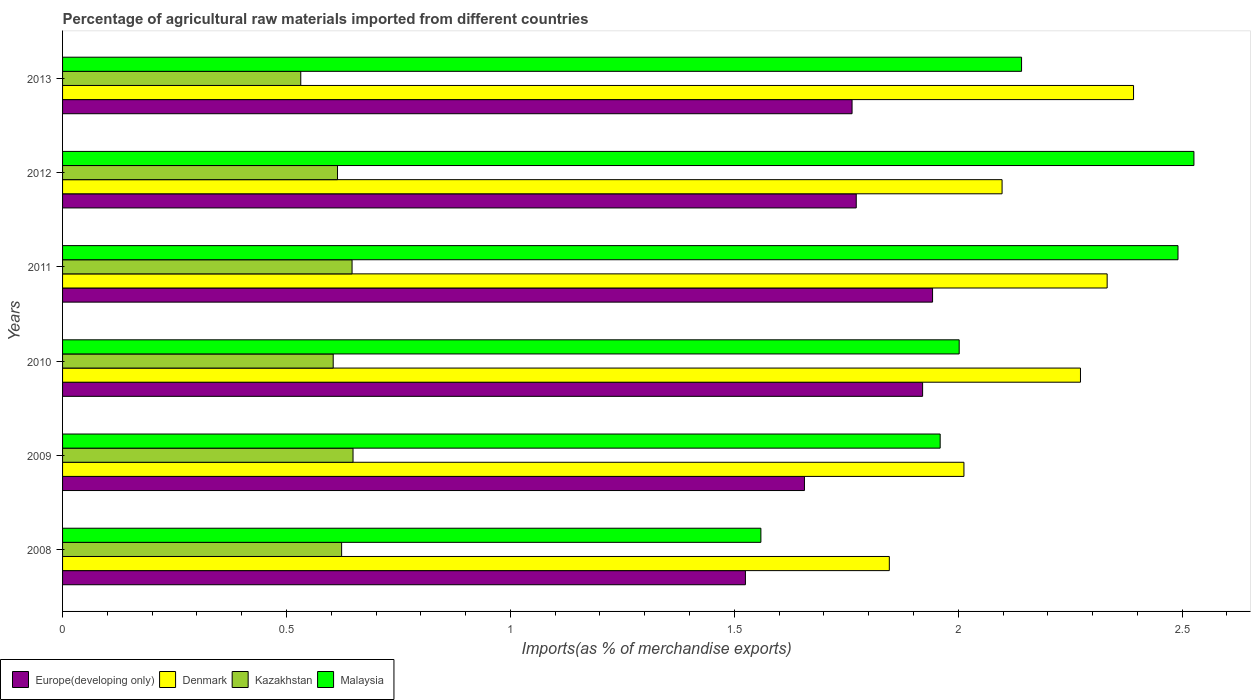Are the number of bars per tick equal to the number of legend labels?
Offer a terse response. Yes. What is the label of the 4th group of bars from the top?
Ensure brevity in your answer.  2010. What is the percentage of imports to different countries in Denmark in 2008?
Give a very brief answer. 1.85. Across all years, what is the maximum percentage of imports to different countries in Malaysia?
Make the answer very short. 2.53. Across all years, what is the minimum percentage of imports to different countries in Malaysia?
Your answer should be very brief. 1.56. What is the total percentage of imports to different countries in Malaysia in the graph?
Make the answer very short. 12.68. What is the difference between the percentage of imports to different countries in Europe(developing only) in 2008 and that in 2009?
Keep it short and to the point. -0.13. What is the difference between the percentage of imports to different countries in Malaysia in 2008 and the percentage of imports to different countries in Denmark in 2012?
Provide a short and direct response. -0.54. What is the average percentage of imports to different countries in Kazakhstan per year?
Your answer should be very brief. 0.61. In the year 2011, what is the difference between the percentage of imports to different countries in Europe(developing only) and percentage of imports to different countries in Malaysia?
Give a very brief answer. -0.55. What is the ratio of the percentage of imports to different countries in Malaysia in 2008 to that in 2013?
Keep it short and to the point. 0.73. Is the percentage of imports to different countries in Kazakhstan in 2008 less than that in 2010?
Your response must be concise. No. What is the difference between the highest and the second highest percentage of imports to different countries in Kazakhstan?
Provide a short and direct response. 0. What is the difference between the highest and the lowest percentage of imports to different countries in Malaysia?
Your answer should be very brief. 0.97. In how many years, is the percentage of imports to different countries in Kazakhstan greater than the average percentage of imports to different countries in Kazakhstan taken over all years?
Your answer should be compact. 4. What does the 1st bar from the bottom in 2008 represents?
Provide a short and direct response. Europe(developing only). Are all the bars in the graph horizontal?
Give a very brief answer. Yes. Are the values on the major ticks of X-axis written in scientific E-notation?
Offer a very short reply. No. Does the graph contain grids?
Your response must be concise. No. How many legend labels are there?
Keep it short and to the point. 4. How are the legend labels stacked?
Offer a terse response. Horizontal. What is the title of the graph?
Make the answer very short. Percentage of agricultural raw materials imported from different countries. Does "India" appear as one of the legend labels in the graph?
Your response must be concise. No. What is the label or title of the X-axis?
Make the answer very short. Imports(as % of merchandise exports). What is the label or title of the Y-axis?
Keep it short and to the point. Years. What is the Imports(as % of merchandise exports) in Europe(developing only) in 2008?
Provide a short and direct response. 1.52. What is the Imports(as % of merchandise exports) in Denmark in 2008?
Give a very brief answer. 1.85. What is the Imports(as % of merchandise exports) of Kazakhstan in 2008?
Your answer should be very brief. 0.62. What is the Imports(as % of merchandise exports) in Malaysia in 2008?
Your answer should be very brief. 1.56. What is the Imports(as % of merchandise exports) in Europe(developing only) in 2009?
Your response must be concise. 1.66. What is the Imports(as % of merchandise exports) in Denmark in 2009?
Your answer should be very brief. 2.01. What is the Imports(as % of merchandise exports) in Kazakhstan in 2009?
Provide a succinct answer. 0.65. What is the Imports(as % of merchandise exports) in Malaysia in 2009?
Your response must be concise. 1.96. What is the Imports(as % of merchandise exports) in Europe(developing only) in 2010?
Keep it short and to the point. 1.92. What is the Imports(as % of merchandise exports) in Denmark in 2010?
Offer a terse response. 2.27. What is the Imports(as % of merchandise exports) of Kazakhstan in 2010?
Provide a succinct answer. 0.6. What is the Imports(as % of merchandise exports) in Malaysia in 2010?
Provide a short and direct response. 2. What is the Imports(as % of merchandise exports) of Europe(developing only) in 2011?
Keep it short and to the point. 1.94. What is the Imports(as % of merchandise exports) of Denmark in 2011?
Give a very brief answer. 2.33. What is the Imports(as % of merchandise exports) of Kazakhstan in 2011?
Provide a short and direct response. 0.65. What is the Imports(as % of merchandise exports) in Malaysia in 2011?
Provide a short and direct response. 2.49. What is the Imports(as % of merchandise exports) of Europe(developing only) in 2012?
Provide a short and direct response. 1.77. What is the Imports(as % of merchandise exports) in Denmark in 2012?
Your response must be concise. 2.1. What is the Imports(as % of merchandise exports) in Kazakhstan in 2012?
Ensure brevity in your answer.  0.61. What is the Imports(as % of merchandise exports) in Malaysia in 2012?
Make the answer very short. 2.53. What is the Imports(as % of merchandise exports) in Europe(developing only) in 2013?
Provide a succinct answer. 1.76. What is the Imports(as % of merchandise exports) in Denmark in 2013?
Ensure brevity in your answer.  2.39. What is the Imports(as % of merchandise exports) in Kazakhstan in 2013?
Offer a very short reply. 0.53. What is the Imports(as % of merchandise exports) of Malaysia in 2013?
Ensure brevity in your answer.  2.14. Across all years, what is the maximum Imports(as % of merchandise exports) of Europe(developing only)?
Ensure brevity in your answer.  1.94. Across all years, what is the maximum Imports(as % of merchandise exports) of Denmark?
Your answer should be compact. 2.39. Across all years, what is the maximum Imports(as % of merchandise exports) of Kazakhstan?
Offer a terse response. 0.65. Across all years, what is the maximum Imports(as % of merchandise exports) in Malaysia?
Give a very brief answer. 2.53. Across all years, what is the minimum Imports(as % of merchandise exports) of Europe(developing only)?
Offer a very short reply. 1.52. Across all years, what is the minimum Imports(as % of merchandise exports) in Denmark?
Make the answer very short. 1.85. Across all years, what is the minimum Imports(as % of merchandise exports) in Kazakhstan?
Your answer should be compact. 0.53. Across all years, what is the minimum Imports(as % of merchandise exports) in Malaysia?
Ensure brevity in your answer.  1.56. What is the total Imports(as % of merchandise exports) of Europe(developing only) in the graph?
Give a very brief answer. 10.58. What is the total Imports(as % of merchandise exports) of Denmark in the graph?
Your response must be concise. 12.95. What is the total Imports(as % of merchandise exports) of Kazakhstan in the graph?
Your response must be concise. 3.67. What is the total Imports(as % of merchandise exports) of Malaysia in the graph?
Your answer should be compact. 12.68. What is the difference between the Imports(as % of merchandise exports) of Europe(developing only) in 2008 and that in 2009?
Offer a very short reply. -0.13. What is the difference between the Imports(as % of merchandise exports) of Denmark in 2008 and that in 2009?
Keep it short and to the point. -0.17. What is the difference between the Imports(as % of merchandise exports) of Kazakhstan in 2008 and that in 2009?
Ensure brevity in your answer.  -0.03. What is the difference between the Imports(as % of merchandise exports) in Malaysia in 2008 and that in 2009?
Provide a short and direct response. -0.4. What is the difference between the Imports(as % of merchandise exports) in Europe(developing only) in 2008 and that in 2010?
Your answer should be compact. -0.4. What is the difference between the Imports(as % of merchandise exports) in Denmark in 2008 and that in 2010?
Make the answer very short. -0.43. What is the difference between the Imports(as % of merchandise exports) of Kazakhstan in 2008 and that in 2010?
Make the answer very short. 0.02. What is the difference between the Imports(as % of merchandise exports) in Malaysia in 2008 and that in 2010?
Offer a very short reply. -0.44. What is the difference between the Imports(as % of merchandise exports) in Europe(developing only) in 2008 and that in 2011?
Your answer should be compact. -0.42. What is the difference between the Imports(as % of merchandise exports) in Denmark in 2008 and that in 2011?
Give a very brief answer. -0.49. What is the difference between the Imports(as % of merchandise exports) of Kazakhstan in 2008 and that in 2011?
Keep it short and to the point. -0.02. What is the difference between the Imports(as % of merchandise exports) in Malaysia in 2008 and that in 2011?
Your answer should be compact. -0.93. What is the difference between the Imports(as % of merchandise exports) in Europe(developing only) in 2008 and that in 2012?
Provide a short and direct response. -0.25. What is the difference between the Imports(as % of merchandise exports) of Denmark in 2008 and that in 2012?
Make the answer very short. -0.25. What is the difference between the Imports(as % of merchandise exports) in Kazakhstan in 2008 and that in 2012?
Provide a short and direct response. 0.01. What is the difference between the Imports(as % of merchandise exports) of Malaysia in 2008 and that in 2012?
Provide a short and direct response. -0.97. What is the difference between the Imports(as % of merchandise exports) of Europe(developing only) in 2008 and that in 2013?
Ensure brevity in your answer.  -0.24. What is the difference between the Imports(as % of merchandise exports) of Denmark in 2008 and that in 2013?
Give a very brief answer. -0.55. What is the difference between the Imports(as % of merchandise exports) in Kazakhstan in 2008 and that in 2013?
Provide a short and direct response. 0.09. What is the difference between the Imports(as % of merchandise exports) in Malaysia in 2008 and that in 2013?
Provide a succinct answer. -0.58. What is the difference between the Imports(as % of merchandise exports) of Europe(developing only) in 2009 and that in 2010?
Offer a very short reply. -0.26. What is the difference between the Imports(as % of merchandise exports) in Denmark in 2009 and that in 2010?
Give a very brief answer. -0.26. What is the difference between the Imports(as % of merchandise exports) of Kazakhstan in 2009 and that in 2010?
Provide a short and direct response. 0.04. What is the difference between the Imports(as % of merchandise exports) in Malaysia in 2009 and that in 2010?
Ensure brevity in your answer.  -0.04. What is the difference between the Imports(as % of merchandise exports) in Europe(developing only) in 2009 and that in 2011?
Keep it short and to the point. -0.29. What is the difference between the Imports(as % of merchandise exports) in Denmark in 2009 and that in 2011?
Provide a succinct answer. -0.32. What is the difference between the Imports(as % of merchandise exports) of Kazakhstan in 2009 and that in 2011?
Provide a succinct answer. 0. What is the difference between the Imports(as % of merchandise exports) of Malaysia in 2009 and that in 2011?
Your response must be concise. -0.53. What is the difference between the Imports(as % of merchandise exports) in Europe(developing only) in 2009 and that in 2012?
Keep it short and to the point. -0.12. What is the difference between the Imports(as % of merchandise exports) of Denmark in 2009 and that in 2012?
Your answer should be very brief. -0.09. What is the difference between the Imports(as % of merchandise exports) of Kazakhstan in 2009 and that in 2012?
Provide a short and direct response. 0.03. What is the difference between the Imports(as % of merchandise exports) of Malaysia in 2009 and that in 2012?
Provide a short and direct response. -0.57. What is the difference between the Imports(as % of merchandise exports) of Europe(developing only) in 2009 and that in 2013?
Ensure brevity in your answer.  -0.11. What is the difference between the Imports(as % of merchandise exports) in Denmark in 2009 and that in 2013?
Ensure brevity in your answer.  -0.38. What is the difference between the Imports(as % of merchandise exports) of Kazakhstan in 2009 and that in 2013?
Your answer should be very brief. 0.12. What is the difference between the Imports(as % of merchandise exports) of Malaysia in 2009 and that in 2013?
Your answer should be very brief. -0.18. What is the difference between the Imports(as % of merchandise exports) of Europe(developing only) in 2010 and that in 2011?
Provide a succinct answer. -0.02. What is the difference between the Imports(as % of merchandise exports) in Denmark in 2010 and that in 2011?
Your response must be concise. -0.06. What is the difference between the Imports(as % of merchandise exports) of Kazakhstan in 2010 and that in 2011?
Make the answer very short. -0.04. What is the difference between the Imports(as % of merchandise exports) in Malaysia in 2010 and that in 2011?
Your answer should be compact. -0.49. What is the difference between the Imports(as % of merchandise exports) in Europe(developing only) in 2010 and that in 2012?
Offer a very short reply. 0.15. What is the difference between the Imports(as % of merchandise exports) in Denmark in 2010 and that in 2012?
Your answer should be compact. 0.18. What is the difference between the Imports(as % of merchandise exports) of Kazakhstan in 2010 and that in 2012?
Your answer should be compact. -0.01. What is the difference between the Imports(as % of merchandise exports) of Malaysia in 2010 and that in 2012?
Offer a very short reply. -0.52. What is the difference between the Imports(as % of merchandise exports) in Europe(developing only) in 2010 and that in 2013?
Provide a succinct answer. 0.16. What is the difference between the Imports(as % of merchandise exports) in Denmark in 2010 and that in 2013?
Give a very brief answer. -0.12. What is the difference between the Imports(as % of merchandise exports) of Kazakhstan in 2010 and that in 2013?
Provide a succinct answer. 0.07. What is the difference between the Imports(as % of merchandise exports) in Malaysia in 2010 and that in 2013?
Provide a short and direct response. -0.14. What is the difference between the Imports(as % of merchandise exports) of Europe(developing only) in 2011 and that in 2012?
Make the answer very short. 0.17. What is the difference between the Imports(as % of merchandise exports) of Denmark in 2011 and that in 2012?
Your response must be concise. 0.23. What is the difference between the Imports(as % of merchandise exports) of Kazakhstan in 2011 and that in 2012?
Give a very brief answer. 0.03. What is the difference between the Imports(as % of merchandise exports) of Malaysia in 2011 and that in 2012?
Ensure brevity in your answer.  -0.04. What is the difference between the Imports(as % of merchandise exports) in Europe(developing only) in 2011 and that in 2013?
Your answer should be very brief. 0.18. What is the difference between the Imports(as % of merchandise exports) of Denmark in 2011 and that in 2013?
Keep it short and to the point. -0.06. What is the difference between the Imports(as % of merchandise exports) in Kazakhstan in 2011 and that in 2013?
Ensure brevity in your answer.  0.11. What is the difference between the Imports(as % of merchandise exports) in Malaysia in 2011 and that in 2013?
Your response must be concise. 0.35. What is the difference between the Imports(as % of merchandise exports) in Europe(developing only) in 2012 and that in 2013?
Provide a succinct answer. 0.01. What is the difference between the Imports(as % of merchandise exports) in Denmark in 2012 and that in 2013?
Provide a short and direct response. -0.29. What is the difference between the Imports(as % of merchandise exports) of Kazakhstan in 2012 and that in 2013?
Offer a very short reply. 0.08. What is the difference between the Imports(as % of merchandise exports) in Malaysia in 2012 and that in 2013?
Give a very brief answer. 0.38. What is the difference between the Imports(as % of merchandise exports) of Europe(developing only) in 2008 and the Imports(as % of merchandise exports) of Denmark in 2009?
Ensure brevity in your answer.  -0.49. What is the difference between the Imports(as % of merchandise exports) in Europe(developing only) in 2008 and the Imports(as % of merchandise exports) in Kazakhstan in 2009?
Your answer should be compact. 0.88. What is the difference between the Imports(as % of merchandise exports) of Europe(developing only) in 2008 and the Imports(as % of merchandise exports) of Malaysia in 2009?
Your response must be concise. -0.43. What is the difference between the Imports(as % of merchandise exports) of Denmark in 2008 and the Imports(as % of merchandise exports) of Kazakhstan in 2009?
Your answer should be very brief. 1.2. What is the difference between the Imports(as % of merchandise exports) in Denmark in 2008 and the Imports(as % of merchandise exports) in Malaysia in 2009?
Offer a very short reply. -0.11. What is the difference between the Imports(as % of merchandise exports) of Kazakhstan in 2008 and the Imports(as % of merchandise exports) of Malaysia in 2009?
Your response must be concise. -1.34. What is the difference between the Imports(as % of merchandise exports) of Europe(developing only) in 2008 and the Imports(as % of merchandise exports) of Denmark in 2010?
Give a very brief answer. -0.75. What is the difference between the Imports(as % of merchandise exports) of Europe(developing only) in 2008 and the Imports(as % of merchandise exports) of Kazakhstan in 2010?
Provide a short and direct response. 0.92. What is the difference between the Imports(as % of merchandise exports) in Europe(developing only) in 2008 and the Imports(as % of merchandise exports) in Malaysia in 2010?
Provide a short and direct response. -0.48. What is the difference between the Imports(as % of merchandise exports) of Denmark in 2008 and the Imports(as % of merchandise exports) of Kazakhstan in 2010?
Provide a succinct answer. 1.24. What is the difference between the Imports(as % of merchandise exports) of Denmark in 2008 and the Imports(as % of merchandise exports) of Malaysia in 2010?
Your answer should be very brief. -0.16. What is the difference between the Imports(as % of merchandise exports) of Kazakhstan in 2008 and the Imports(as % of merchandise exports) of Malaysia in 2010?
Give a very brief answer. -1.38. What is the difference between the Imports(as % of merchandise exports) of Europe(developing only) in 2008 and the Imports(as % of merchandise exports) of Denmark in 2011?
Provide a succinct answer. -0.81. What is the difference between the Imports(as % of merchandise exports) of Europe(developing only) in 2008 and the Imports(as % of merchandise exports) of Kazakhstan in 2011?
Provide a succinct answer. 0.88. What is the difference between the Imports(as % of merchandise exports) in Europe(developing only) in 2008 and the Imports(as % of merchandise exports) in Malaysia in 2011?
Provide a succinct answer. -0.97. What is the difference between the Imports(as % of merchandise exports) in Denmark in 2008 and the Imports(as % of merchandise exports) in Kazakhstan in 2011?
Your response must be concise. 1.2. What is the difference between the Imports(as % of merchandise exports) of Denmark in 2008 and the Imports(as % of merchandise exports) of Malaysia in 2011?
Make the answer very short. -0.64. What is the difference between the Imports(as % of merchandise exports) of Kazakhstan in 2008 and the Imports(as % of merchandise exports) of Malaysia in 2011?
Offer a terse response. -1.87. What is the difference between the Imports(as % of merchandise exports) of Europe(developing only) in 2008 and the Imports(as % of merchandise exports) of Denmark in 2012?
Your answer should be very brief. -0.57. What is the difference between the Imports(as % of merchandise exports) of Europe(developing only) in 2008 and the Imports(as % of merchandise exports) of Kazakhstan in 2012?
Your answer should be very brief. 0.91. What is the difference between the Imports(as % of merchandise exports) of Europe(developing only) in 2008 and the Imports(as % of merchandise exports) of Malaysia in 2012?
Offer a very short reply. -1. What is the difference between the Imports(as % of merchandise exports) of Denmark in 2008 and the Imports(as % of merchandise exports) of Kazakhstan in 2012?
Provide a short and direct response. 1.23. What is the difference between the Imports(as % of merchandise exports) of Denmark in 2008 and the Imports(as % of merchandise exports) of Malaysia in 2012?
Make the answer very short. -0.68. What is the difference between the Imports(as % of merchandise exports) in Kazakhstan in 2008 and the Imports(as % of merchandise exports) in Malaysia in 2012?
Your response must be concise. -1.9. What is the difference between the Imports(as % of merchandise exports) of Europe(developing only) in 2008 and the Imports(as % of merchandise exports) of Denmark in 2013?
Your answer should be compact. -0.87. What is the difference between the Imports(as % of merchandise exports) in Europe(developing only) in 2008 and the Imports(as % of merchandise exports) in Malaysia in 2013?
Offer a very short reply. -0.62. What is the difference between the Imports(as % of merchandise exports) in Denmark in 2008 and the Imports(as % of merchandise exports) in Kazakhstan in 2013?
Your response must be concise. 1.31. What is the difference between the Imports(as % of merchandise exports) in Denmark in 2008 and the Imports(as % of merchandise exports) in Malaysia in 2013?
Offer a very short reply. -0.3. What is the difference between the Imports(as % of merchandise exports) of Kazakhstan in 2008 and the Imports(as % of merchandise exports) of Malaysia in 2013?
Your response must be concise. -1.52. What is the difference between the Imports(as % of merchandise exports) of Europe(developing only) in 2009 and the Imports(as % of merchandise exports) of Denmark in 2010?
Make the answer very short. -0.62. What is the difference between the Imports(as % of merchandise exports) of Europe(developing only) in 2009 and the Imports(as % of merchandise exports) of Kazakhstan in 2010?
Your answer should be compact. 1.05. What is the difference between the Imports(as % of merchandise exports) in Europe(developing only) in 2009 and the Imports(as % of merchandise exports) in Malaysia in 2010?
Offer a terse response. -0.35. What is the difference between the Imports(as % of merchandise exports) in Denmark in 2009 and the Imports(as % of merchandise exports) in Kazakhstan in 2010?
Provide a short and direct response. 1.41. What is the difference between the Imports(as % of merchandise exports) in Denmark in 2009 and the Imports(as % of merchandise exports) in Malaysia in 2010?
Give a very brief answer. 0.01. What is the difference between the Imports(as % of merchandise exports) of Kazakhstan in 2009 and the Imports(as % of merchandise exports) of Malaysia in 2010?
Provide a succinct answer. -1.35. What is the difference between the Imports(as % of merchandise exports) of Europe(developing only) in 2009 and the Imports(as % of merchandise exports) of Denmark in 2011?
Your answer should be very brief. -0.68. What is the difference between the Imports(as % of merchandise exports) in Europe(developing only) in 2009 and the Imports(as % of merchandise exports) in Kazakhstan in 2011?
Give a very brief answer. 1.01. What is the difference between the Imports(as % of merchandise exports) in Europe(developing only) in 2009 and the Imports(as % of merchandise exports) in Malaysia in 2011?
Offer a very short reply. -0.83. What is the difference between the Imports(as % of merchandise exports) of Denmark in 2009 and the Imports(as % of merchandise exports) of Kazakhstan in 2011?
Offer a terse response. 1.37. What is the difference between the Imports(as % of merchandise exports) in Denmark in 2009 and the Imports(as % of merchandise exports) in Malaysia in 2011?
Give a very brief answer. -0.48. What is the difference between the Imports(as % of merchandise exports) of Kazakhstan in 2009 and the Imports(as % of merchandise exports) of Malaysia in 2011?
Keep it short and to the point. -1.84. What is the difference between the Imports(as % of merchandise exports) of Europe(developing only) in 2009 and the Imports(as % of merchandise exports) of Denmark in 2012?
Offer a terse response. -0.44. What is the difference between the Imports(as % of merchandise exports) of Europe(developing only) in 2009 and the Imports(as % of merchandise exports) of Kazakhstan in 2012?
Provide a short and direct response. 1.04. What is the difference between the Imports(as % of merchandise exports) in Europe(developing only) in 2009 and the Imports(as % of merchandise exports) in Malaysia in 2012?
Give a very brief answer. -0.87. What is the difference between the Imports(as % of merchandise exports) in Denmark in 2009 and the Imports(as % of merchandise exports) in Kazakhstan in 2012?
Provide a short and direct response. 1.4. What is the difference between the Imports(as % of merchandise exports) in Denmark in 2009 and the Imports(as % of merchandise exports) in Malaysia in 2012?
Your answer should be very brief. -0.51. What is the difference between the Imports(as % of merchandise exports) in Kazakhstan in 2009 and the Imports(as % of merchandise exports) in Malaysia in 2012?
Offer a very short reply. -1.88. What is the difference between the Imports(as % of merchandise exports) of Europe(developing only) in 2009 and the Imports(as % of merchandise exports) of Denmark in 2013?
Keep it short and to the point. -0.73. What is the difference between the Imports(as % of merchandise exports) in Europe(developing only) in 2009 and the Imports(as % of merchandise exports) in Kazakhstan in 2013?
Ensure brevity in your answer.  1.12. What is the difference between the Imports(as % of merchandise exports) of Europe(developing only) in 2009 and the Imports(as % of merchandise exports) of Malaysia in 2013?
Make the answer very short. -0.48. What is the difference between the Imports(as % of merchandise exports) in Denmark in 2009 and the Imports(as % of merchandise exports) in Kazakhstan in 2013?
Keep it short and to the point. 1.48. What is the difference between the Imports(as % of merchandise exports) in Denmark in 2009 and the Imports(as % of merchandise exports) in Malaysia in 2013?
Offer a very short reply. -0.13. What is the difference between the Imports(as % of merchandise exports) in Kazakhstan in 2009 and the Imports(as % of merchandise exports) in Malaysia in 2013?
Give a very brief answer. -1.49. What is the difference between the Imports(as % of merchandise exports) of Europe(developing only) in 2010 and the Imports(as % of merchandise exports) of Denmark in 2011?
Your response must be concise. -0.41. What is the difference between the Imports(as % of merchandise exports) in Europe(developing only) in 2010 and the Imports(as % of merchandise exports) in Kazakhstan in 2011?
Your answer should be very brief. 1.27. What is the difference between the Imports(as % of merchandise exports) of Europe(developing only) in 2010 and the Imports(as % of merchandise exports) of Malaysia in 2011?
Ensure brevity in your answer.  -0.57. What is the difference between the Imports(as % of merchandise exports) of Denmark in 2010 and the Imports(as % of merchandise exports) of Kazakhstan in 2011?
Keep it short and to the point. 1.63. What is the difference between the Imports(as % of merchandise exports) in Denmark in 2010 and the Imports(as % of merchandise exports) in Malaysia in 2011?
Offer a very short reply. -0.22. What is the difference between the Imports(as % of merchandise exports) in Kazakhstan in 2010 and the Imports(as % of merchandise exports) in Malaysia in 2011?
Your answer should be very brief. -1.89. What is the difference between the Imports(as % of merchandise exports) in Europe(developing only) in 2010 and the Imports(as % of merchandise exports) in Denmark in 2012?
Make the answer very short. -0.18. What is the difference between the Imports(as % of merchandise exports) of Europe(developing only) in 2010 and the Imports(as % of merchandise exports) of Kazakhstan in 2012?
Ensure brevity in your answer.  1.31. What is the difference between the Imports(as % of merchandise exports) of Europe(developing only) in 2010 and the Imports(as % of merchandise exports) of Malaysia in 2012?
Ensure brevity in your answer.  -0.61. What is the difference between the Imports(as % of merchandise exports) of Denmark in 2010 and the Imports(as % of merchandise exports) of Kazakhstan in 2012?
Provide a succinct answer. 1.66. What is the difference between the Imports(as % of merchandise exports) of Denmark in 2010 and the Imports(as % of merchandise exports) of Malaysia in 2012?
Provide a short and direct response. -0.25. What is the difference between the Imports(as % of merchandise exports) of Kazakhstan in 2010 and the Imports(as % of merchandise exports) of Malaysia in 2012?
Your response must be concise. -1.92. What is the difference between the Imports(as % of merchandise exports) of Europe(developing only) in 2010 and the Imports(as % of merchandise exports) of Denmark in 2013?
Provide a short and direct response. -0.47. What is the difference between the Imports(as % of merchandise exports) of Europe(developing only) in 2010 and the Imports(as % of merchandise exports) of Kazakhstan in 2013?
Ensure brevity in your answer.  1.39. What is the difference between the Imports(as % of merchandise exports) in Europe(developing only) in 2010 and the Imports(as % of merchandise exports) in Malaysia in 2013?
Make the answer very short. -0.22. What is the difference between the Imports(as % of merchandise exports) in Denmark in 2010 and the Imports(as % of merchandise exports) in Kazakhstan in 2013?
Provide a short and direct response. 1.74. What is the difference between the Imports(as % of merchandise exports) of Denmark in 2010 and the Imports(as % of merchandise exports) of Malaysia in 2013?
Make the answer very short. 0.13. What is the difference between the Imports(as % of merchandise exports) in Kazakhstan in 2010 and the Imports(as % of merchandise exports) in Malaysia in 2013?
Ensure brevity in your answer.  -1.54. What is the difference between the Imports(as % of merchandise exports) in Europe(developing only) in 2011 and the Imports(as % of merchandise exports) in Denmark in 2012?
Keep it short and to the point. -0.16. What is the difference between the Imports(as % of merchandise exports) in Europe(developing only) in 2011 and the Imports(as % of merchandise exports) in Kazakhstan in 2012?
Your answer should be very brief. 1.33. What is the difference between the Imports(as % of merchandise exports) in Europe(developing only) in 2011 and the Imports(as % of merchandise exports) in Malaysia in 2012?
Provide a succinct answer. -0.58. What is the difference between the Imports(as % of merchandise exports) of Denmark in 2011 and the Imports(as % of merchandise exports) of Kazakhstan in 2012?
Keep it short and to the point. 1.72. What is the difference between the Imports(as % of merchandise exports) of Denmark in 2011 and the Imports(as % of merchandise exports) of Malaysia in 2012?
Offer a terse response. -0.19. What is the difference between the Imports(as % of merchandise exports) in Kazakhstan in 2011 and the Imports(as % of merchandise exports) in Malaysia in 2012?
Keep it short and to the point. -1.88. What is the difference between the Imports(as % of merchandise exports) of Europe(developing only) in 2011 and the Imports(as % of merchandise exports) of Denmark in 2013?
Make the answer very short. -0.45. What is the difference between the Imports(as % of merchandise exports) in Europe(developing only) in 2011 and the Imports(as % of merchandise exports) in Kazakhstan in 2013?
Offer a very short reply. 1.41. What is the difference between the Imports(as % of merchandise exports) in Europe(developing only) in 2011 and the Imports(as % of merchandise exports) in Malaysia in 2013?
Your answer should be compact. -0.2. What is the difference between the Imports(as % of merchandise exports) in Denmark in 2011 and the Imports(as % of merchandise exports) in Kazakhstan in 2013?
Provide a short and direct response. 1.8. What is the difference between the Imports(as % of merchandise exports) in Denmark in 2011 and the Imports(as % of merchandise exports) in Malaysia in 2013?
Your answer should be very brief. 0.19. What is the difference between the Imports(as % of merchandise exports) in Kazakhstan in 2011 and the Imports(as % of merchandise exports) in Malaysia in 2013?
Provide a succinct answer. -1.5. What is the difference between the Imports(as % of merchandise exports) in Europe(developing only) in 2012 and the Imports(as % of merchandise exports) in Denmark in 2013?
Ensure brevity in your answer.  -0.62. What is the difference between the Imports(as % of merchandise exports) of Europe(developing only) in 2012 and the Imports(as % of merchandise exports) of Kazakhstan in 2013?
Your response must be concise. 1.24. What is the difference between the Imports(as % of merchandise exports) of Europe(developing only) in 2012 and the Imports(as % of merchandise exports) of Malaysia in 2013?
Ensure brevity in your answer.  -0.37. What is the difference between the Imports(as % of merchandise exports) of Denmark in 2012 and the Imports(as % of merchandise exports) of Kazakhstan in 2013?
Your answer should be compact. 1.57. What is the difference between the Imports(as % of merchandise exports) of Denmark in 2012 and the Imports(as % of merchandise exports) of Malaysia in 2013?
Your answer should be compact. -0.04. What is the difference between the Imports(as % of merchandise exports) of Kazakhstan in 2012 and the Imports(as % of merchandise exports) of Malaysia in 2013?
Keep it short and to the point. -1.53. What is the average Imports(as % of merchandise exports) of Europe(developing only) per year?
Offer a terse response. 1.76. What is the average Imports(as % of merchandise exports) of Denmark per year?
Your answer should be very brief. 2.16. What is the average Imports(as % of merchandise exports) of Kazakhstan per year?
Offer a terse response. 0.61. What is the average Imports(as % of merchandise exports) in Malaysia per year?
Provide a succinct answer. 2.11. In the year 2008, what is the difference between the Imports(as % of merchandise exports) of Europe(developing only) and Imports(as % of merchandise exports) of Denmark?
Offer a very short reply. -0.32. In the year 2008, what is the difference between the Imports(as % of merchandise exports) in Europe(developing only) and Imports(as % of merchandise exports) in Kazakhstan?
Provide a succinct answer. 0.9. In the year 2008, what is the difference between the Imports(as % of merchandise exports) of Europe(developing only) and Imports(as % of merchandise exports) of Malaysia?
Your answer should be very brief. -0.03. In the year 2008, what is the difference between the Imports(as % of merchandise exports) in Denmark and Imports(as % of merchandise exports) in Kazakhstan?
Your response must be concise. 1.22. In the year 2008, what is the difference between the Imports(as % of merchandise exports) of Denmark and Imports(as % of merchandise exports) of Malaysia?
Your answer should be very brief. 0.29. In the year 2008, what is the difference between the Imports(as % of merchandise exports) of Kazakhstan and Imports(as % of merchandise exports) of Malaysia?
Offer a terse response. -0.94. In the year 2009, what is the difference between the Imports(as % of merchandise exports) in Europe(developing only) and Imports(as % of merchandise exports) in Denmark?
Your answer should be very brief. -0.36. In the year 2009, what is the difference between the Imports(as % of merchandise exports) of Europe(developing only) and Imports(as % of merchandise exports) of Kazakhstan?
Ensure brevity in your answer.  1.01. In the year 2009, what is the difference between the Imports(as % of merchandise exports) in Europe(developing only) and Imports(as % of merchandise exports) in Malaysia?
Offer a terse response. -0.3. In the year 2009, what is the difference between the Imports(as % of merchandise exports) of Denmark and Imports(as % of merchandise exports) of Kazakhstan?
Keep it short and to the point. 1.36. In the year 2009, what is the difference between the Imports(as % of merchandise exports) in Denmark and Imports(as % of merchandise exports) in Malaysia?
Offer a terse response. 0.05. In the year 2009, what is the difference between the Imports(as % of merchandise exports) of Kazakhstan and Imports(as % of merchandise exports) of Malaysia?
Give a very brief answer. -1.31. In the year 2010, what is the difference between the Imports(as % of merchandise exports) in Europe(developing only) and Imports(as % of merchandise exports) in Denmark?
Keep it short and to the point. -0.35. In the year 2010, what is the difference between the Imports(as % of merchandise exports) of Europe(developing only) and Imports(as % of merchandise exports) of Kazakhstan?
Your response must be concise. 1.32. In the year 2010, what is the difference between the Imports(as % of merchandise exports) in Europe(developing only) and Imports(as % of merchandise exports) in Malaysia?
Your response must be concise. -0.08. In the year 2010, what is the difference between the Imports(as % of merchandise exports) of Denmark and Imports(as % of merchandise exports) of Kazakhstan?
Your response must be concise. 1.67. In the year 2010, what is the difference between the Imports(as % of merchandise exports) in Denmark and Imports(as % of merchandise exports) in Malaysia?
Your answer should be very brief. 0.27. In the year 2010, what is the difference between the Imports(as % of merchandise exports) in Kazakhstan and Imports(as % of merchandise exports) in Malaysia?
Offer a terse response. -1.4. In the year 2011, what is the difference between the Imports(as % of merchandise exports) of Europe(developing only) and Imports(as % of merchandise exports) of Denmark?
Give a very brief answer. -0.39. In the year 2011, what is the difference between the Imports(as % of merchandise exports) of Europe(developing only) and Imports(as % of merchandise exports) of Kazakhstan?
Your answer should be compact. 1.3. In the year 2011, what is the difference between the Imports(as % of merchandise exports) of Europe(developing only) and Imports(as % of merchandise exports) of Malaysia?
Your answer should be very brief. -0.55. In the year 2011, what is the difference between the Imports(as % of merchandise exports) in Denmark and Imports(as % of merchandise exports) in Kazakhstan?
Offer a terse response. 1.69. In the year 2011, what is the difference between the Imports(as % of merchandise exports) of Denmark and Imports(as % of merchandise exports) of Malaysia?
Offer a very short reply. -0.16. In the year 2011, what is the difference between the Imports(as % of merchandise exports) in Kazakhstan and Imports(as % of merchandise exports) in Malaysia?
Ensure brevity in your answer.  -1.84. In the year 2012, what is the difference between the Imports(as % of merchandise exports) in Europe(developing only) and Imports(as % of merchandise exports) in Denmark?
Offer a terse response. -0.33. In the year 2012, what is the difference between the Imports(as % of merchandise exports) in Europe(developing only) and Imports(as % of merchandise exports) in Kazakhstan?
Your answer should be compact. 1.16. In the year 2012, what is the difference between the Imports(as % of merchandise exports) in Europe(developing only) and Imports(as % of merchandise exports) in Malaysia?
Provide a succinct answer. -0.75. In the year 2012, what is the difference between the Imports(as % of merchandise exports) of Denmark and Imports(as % of merchandise exports) of Kazakhstan?
Keep it short and to the point. 1.48. In the year 2012, what is the difference between the Imports(as % of merchandise exports) in Denmark and Imports(as % of merchandise exports) in Malaysia?
Your answer should be compact. -0.43. In the year 2012, what is the difference between the Imports(as % of merchandise exports) of Kazakhstan and Imports(as % of merchandise exports) of Malaysia?
Your answer should be very brief. -1.91. In the year 2013, what is the difference between the Imports(as % of merchandise exports) of Europe(developing only) and Imports(as % of merchandise exports) of Denmark?
Offer a very short reply. -0.63. In the year 2013, what is the difference between the Imports(as % of merchandise exports) in Europe(developing only) and Imports(as % of merchandise exports) in Kazakhstan?
Your answer should be very brief. 1.23. In the year 2013, what is the difference between the Imports(as % of merchandise exports) of Europe(developing only) and Imports(as % of merchandise exports) of Malaysia?
Ensure brevity in your answer.  -0.38. In the year 2013, what is the difference between the Imports(as % of merchandise exports) of Denmark and Imports(as % of merchandise exports) of Kazakhstan?
Offer a very short reply. 1.86. In the year 2013, what is the difference between the Imports(as % of merchandise exports) in Denmark and Imports(as % of merchandise exports) in Malaysia?
Your response must be concise. 0.25. In the year 2013, what is the difference between the Imports(as % of merchandise exports) in Kazakhstan and Imports(as % of merchandise exports) in Malaysia?
Ensure brevity in your answer.  -1.61. What is the ratio of the Imports(as % of merchandise exports) in Europe(developing only) in 2008 to that in 2009?
Your answer should be compact. 0.92. What is the ratio of the Imports(as % of merchandise exports) in Denmark in 2008 to that in 2009?
Your answer should be compact. 0.92. What is the ratio of the Imports(as % of merchandise exports) in Kazakhstan in 2008 to that in 2009?
Provide a succinct answer. 0.96. What is the ratio of the Imports(as % of merchandise exports) in Malaysia in 2008 to that in 2009?
Your answer should be compact. 0.8. What is the ratio of the Imports(as % of merchandise exports) in Europe(developing only) in 2008 to that in 2010?
Your answer should be very brief. 0.79. What is the ratio of the Imports(as % of merchandise exports) of Denmark in 2008 to that in 2010?
Make the answer very short. 0.81. What is the ratio of the Imports(as % of merchandise exports) of Kazakhstan in 2008 to that in 2010?
Provide a succinct answer. 1.03. What is the ratio of the Imports(as % of merchandise exports) of Malaysia in 2008 to that in 2010?
Provide a succinct answer. 0.78. What is the ratio of the Imports(as % of merchandise exports) in Europe(developing only) in 2008 to that in 2011?
Your answer should be very brief. 0.78. What is the ratio of the Imports(as % of merchandise exports) in Denmark in 2008 to that in 2011?
Your answer should be compact. 0.79. What is the ratio of the Imports(as % of merchandise exports) of Kazakhstan in 2008 to that in 2011?
Your answer should be compact. 0.96. What is the ratio of the Imports(as % of merchandise exports) in Malaysia in 2008 to that in 2011?
Offer a terse response. 0.63. What is the ratio of the Imports(as % of merchandise exports) in Europe(developing only) in 2008 to that in 2012?
Offer a very short reply. 0.86. What is the ratio of the Imports(as % of merchandise exports) of Kazakhstan in 2008 to that in 2012?
Provide a short and direct response. 1.01. What is the ratio of the Imports(as % of merchandise exports) of Malaysia in 2008 to that in 2012?
Offer a terse response. 0.62. What is the ratio of the Imports(as % of merchandise exports) of Europe(developing only) in 2008 to that in 2013?
Ensure brevity in your answer.  0.86. What is the ratio of the Imports(as % of merchandise exports) in Denmark in 2008 to that in 2013?
Keep it short and to the point. 0.77. What is the ratio of the Imports(as % of merchandise exports) in Kazakhstan in 2008 to that in 2013?
Offer a very short reply. 1.17. What is the ratio of the Imports(as % of merchandise exports) in Malaysia in 2008 to that in 2013?
Your response must be concise. 0.73. What is the ratio of the Imports(as % of merchandise exports) in Europe(developing only) in 2009 to that in 2010?
Provide a succinct answer. 0.86. What is the ratio of the Imports(as % of merchandise exports) of Denmark in 2009 to that in 2010?
Give a very brief answer. 0.89. What is the ratio of the Imports(as % of merchandise exports) of Kazakhstan in 2009 to that in 2010?
Keep it short and to the point. 1.07. What is the ratio of the Imports(as % of merchandise exports) of Malaysia in 2009 to that in 2010?
Keep it short and to the point. 0.98. What is the ratio of the Imports(as % of merchandise exports) in Europe(developing only) in 2009 to that in 2011?
Offer a terse response. 0.85. What is the ratio of the Imports(as % of merchandise exports) of Denmark in 2009 to that in 2011?
Keep it short and to the point. 0.86. What is the ratio of the Imports(as % of merchandise exports) in Malaysia in 2009 to that in 2011?
Offer a terse response. 0.79. What is the ratio of the Imports(as % of merchandise exports) in Europe(developing only) in 2009 to that in 2012?
Offer a very short reply. 0.93. What is the ratio of the Imports(as % of merchandise exports) of Denmark in 2009 to that in 2012?
Offer a terse response. 0.96. What is the ratio of the Imports(as % of merchandise exports) in Kazakhstan in 2009 to that in 2012?
Give a very brief answer. 1.06. What is the ratio of the Imports(as % of merchandise exports) in Malaysia in 2009 to that in 2012?
Provide a succinct answer. 0.78. What is the ratio of the Imports(as % of merchandise exports) of Europe(developing only) in 2009 to that in 2013?
Provide a succinct answer. 0.94. What is the ratio of the Imports(as % of merchandise exports) in Denmark in 2009 to that in 2013?
Provide a succinct answer. 0.84. What is the ratio of the Imports(as % of merchandise exports) in Kazakhstan in 2009 to that in 2013?
Your answer should be very brief. 1.22. What is the ratio of the Imports(as % of merchandise exports) of Malaysia in 2009 to that in 2013?
Your answer should be compact. 0.92. What is the ratio of the Imports(as % of merchandise exports) in Europe(developing only) in 2010 to that in 2011?
Ensure brevity in your answer.  0.99. What is the ratio of the Imports(as % of merchandise exports) in Denmark in 2010 to that in 2011?
Your answer should be compact. 0.97. What is the ratio of the Imports(as % of merchandise exports) in Kazakhstan in 2010 to that in 2011?
Offer a very short reply. 0.93. What is the ratio of the Imports(as % of merchandise exports) in Malaysia in 2010 to that in 2011?
Provide a succinct answer. 0.8. What is the ratio of the Imports(as % of merchandise exports) of Europe(developing only) in 2010 to that in 2012?
Make the answer very short. 1.08. What is the ratio of the Imports(as % of merchandise exports) of Denmark in 2010 to that in 2012?
Provide a succinct answer. 1.08. What is the ratio of the Imports(as % of merchandise exports) of Kazakhstan in 2010 to that in 2012?
Your response must be concise. 0.98. What is the ratio of the Imports(as % of merchandise exports) in Malaysia in 2010 to that in 2012?
Give a very brief answer. 0.79. What is the ratio of the Imports(as % of merchandise exports) in Europe(developing only) in 2010 to that in 2013?
Give a very brief answer. 1.09. What is the ratio of the Imports(as % of merchandise exports) of Denmark in 2010 to that in 2013?
Offer a terse response. 0.95. What is the ratio of the Imports(as % of merchandise exports) in Kazakhstan in 2010 to that in 2013?
Give a very brief answer. 1.14. What is the ratio of the Imports(as % of merchandise exports) of Malaysia in 2010 to that in 2013?
Make the answer very short. 0.93. What is the ratio of the Imports(as % of merchandise exports) in Europe(developing only) in 2011 to that in 2012?
Make the answer very short. 1.1. What is the ratio of the Imports(as % of merchandise exports) in Denmark in 2011 to that in 2012?
Provide a succinct answer. 1.11. What is the ratio of the Imports(as % of merchandise exports) in Kazakhstan in 2011 to that in 2012?
Make the answer very short. 1.05. What is the ratio of the Imports(as % of merchandise exports) in Malaysia in 2011 to that in 2012?
Make the answer very short. 0.99. What is the ratio of the Imports(as % of merchandise exports) of Europe(developing only) in 2011 to that in 2013?
Provide a succinct answer. 1.1. What is the ratio of the Imports(as % of merchandise exports) in Denmark in 2011 to that in 2013?
Your answer should be compact. 0.98. What is the ratio of the Imports(as % of merchandise exports) of Kazakhstan in 2011 to that in 2013?
Your answer should be very brief. 1.22. What is the ratio of the Imports(as % of merchandise exports) of Malaysia in 2011 to that in 2013?
Keep it short and to the point. 1.16. What is the ratio of the Imports(as % of merchandise exports) in Europe(developing only) in 2012 to that in 2013?
Provide a short and direct response. 1.01. What is the ratio of the Imports(as % of merchandise exports) in Denmark in 2012 to that in 2013?
Provide a short and direct response. 0.88. What is the ratio of the Imports(as % of merchandise exports) in Kazakhstan in 2012 to that in 2013?
Make the answer very short. 1.15. What is the ratio of the Imports(as % of merchandise exports) of Malaysia in 2012 to that in 2013?
Offer a very short reply. 1.18. What is the difference between the highest and the second highest Imports(as % of merchandise exports) of Europe(developing only)?
Provide a short and direct response. 0.02. What is the difference between the highest and the second highest Imports(as % of merchandise exports) of Denmark?
Give a very brief answer. 0.06. What is the difference between the highest and the second highest Imports(as % of merchandise exports) of Kazakhstan?
Make the answer very short. 0. What is the difference between the highest and the second highest Imports(as % of merchandise exports) of Malaysia?
Keep it short and to the point. 0.04. What is the difference between the highest and the lowest Imports(as % of merchandise exports) in Europe(developing only)?
Offer a very short reply. 0.42. What is the difference between the highest and the lowest Imports(as % of merchandise exports) of Denmark?
Keep it short and to the point. 0.55. What is the difference between the highest and the lowest Imports(as % of merchandise exports) in Kazakhstan?
Give a very brief answer. 0.12. What is the difference between the highest and the lowest Imports(as % of merchandise exports) of Malaysia?
Provide a short and direct response. 0.97. 